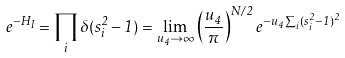Convert formula to latex. <formula><loc_0><loc_0><loc_500><loc_500>e ^ { - H _ { I } } = \prod _ { i } \delta ( { s } _ { i } ^ { 2 } - 1 ) = \lim _ { u _ { 4 } \to \infty } \left ( { \frac { u _ { 4 } } { \pi } } \right ) ^ { N / 2 } e ^ { - u _ { 4 } \sum _ { i } ( { s } _ { i } ^ { 2 } - 1 ) ^ { 2 } }</formula> 